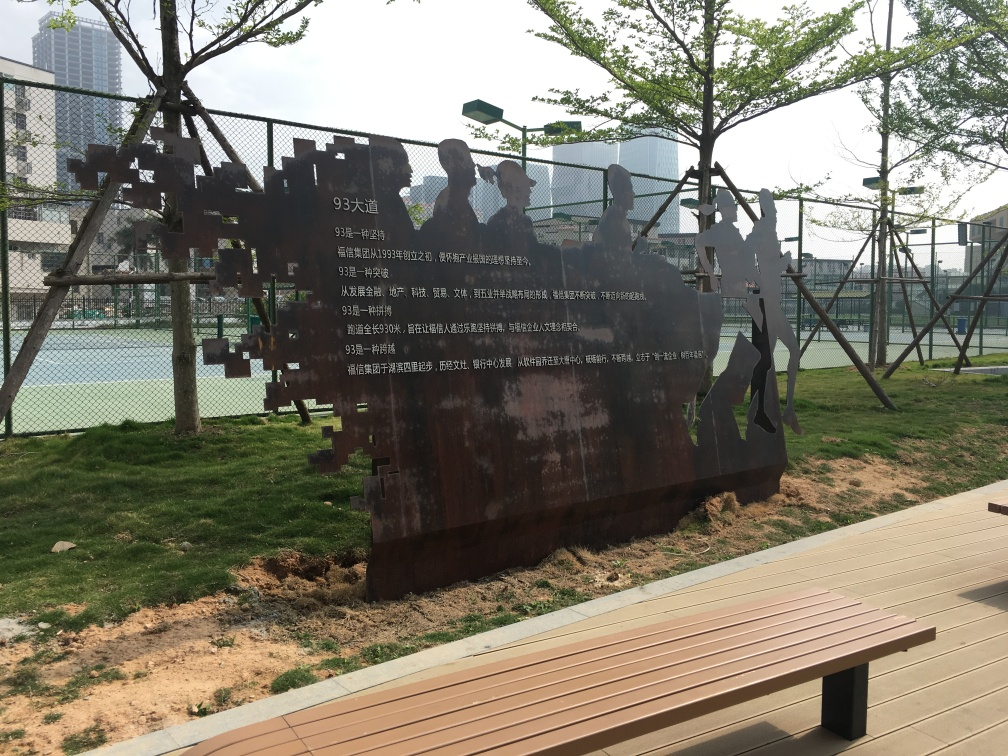Can you tell me about the art installation featured in the photo? Certainly! The image showcases an intriguing metal art installation that appears to represent human figures involved in a community or social activity. It's constructed from rusted metal, which gives it an industrial yet historical aesthetic, and it's set against the backdrop of an urban park. The figures are interconnected, hinting at a theme of unity or interdependence among the people they represent. 